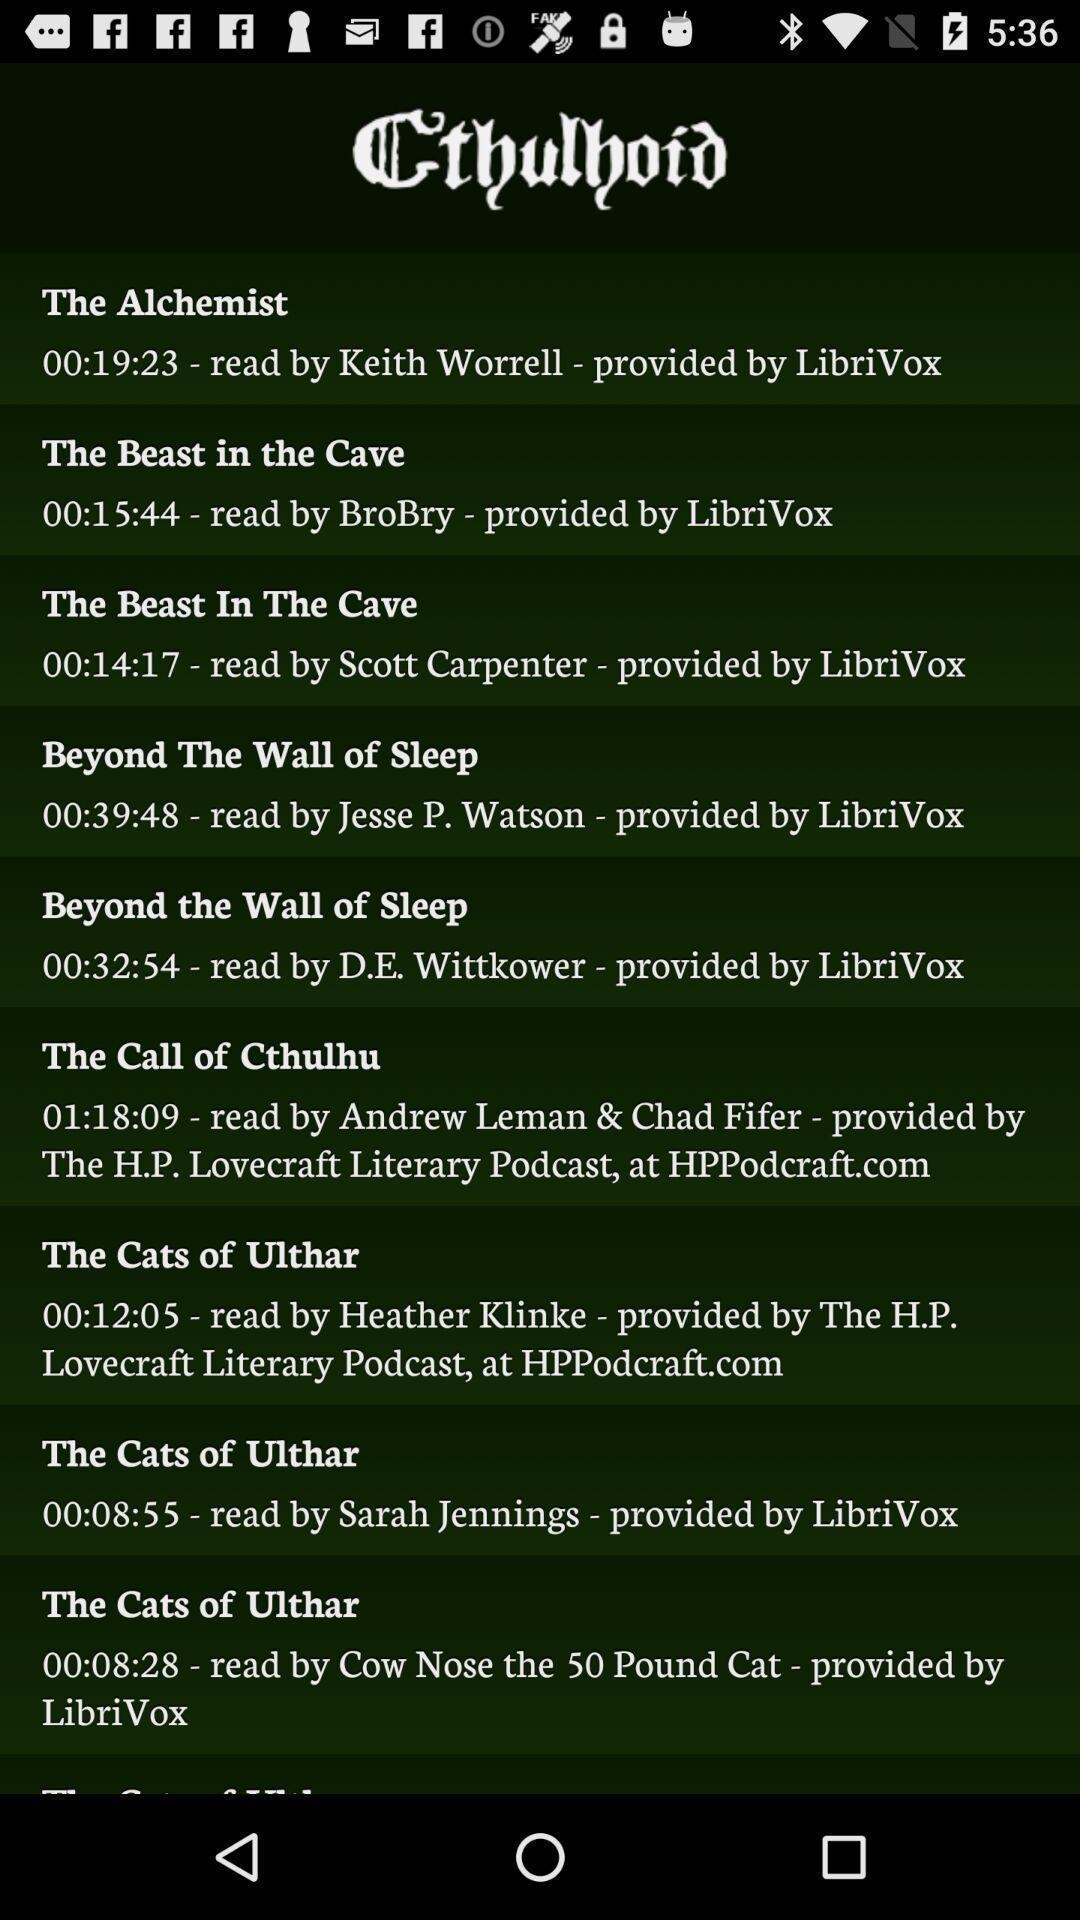What details can you identify in this image? Screen displaying list of books. 